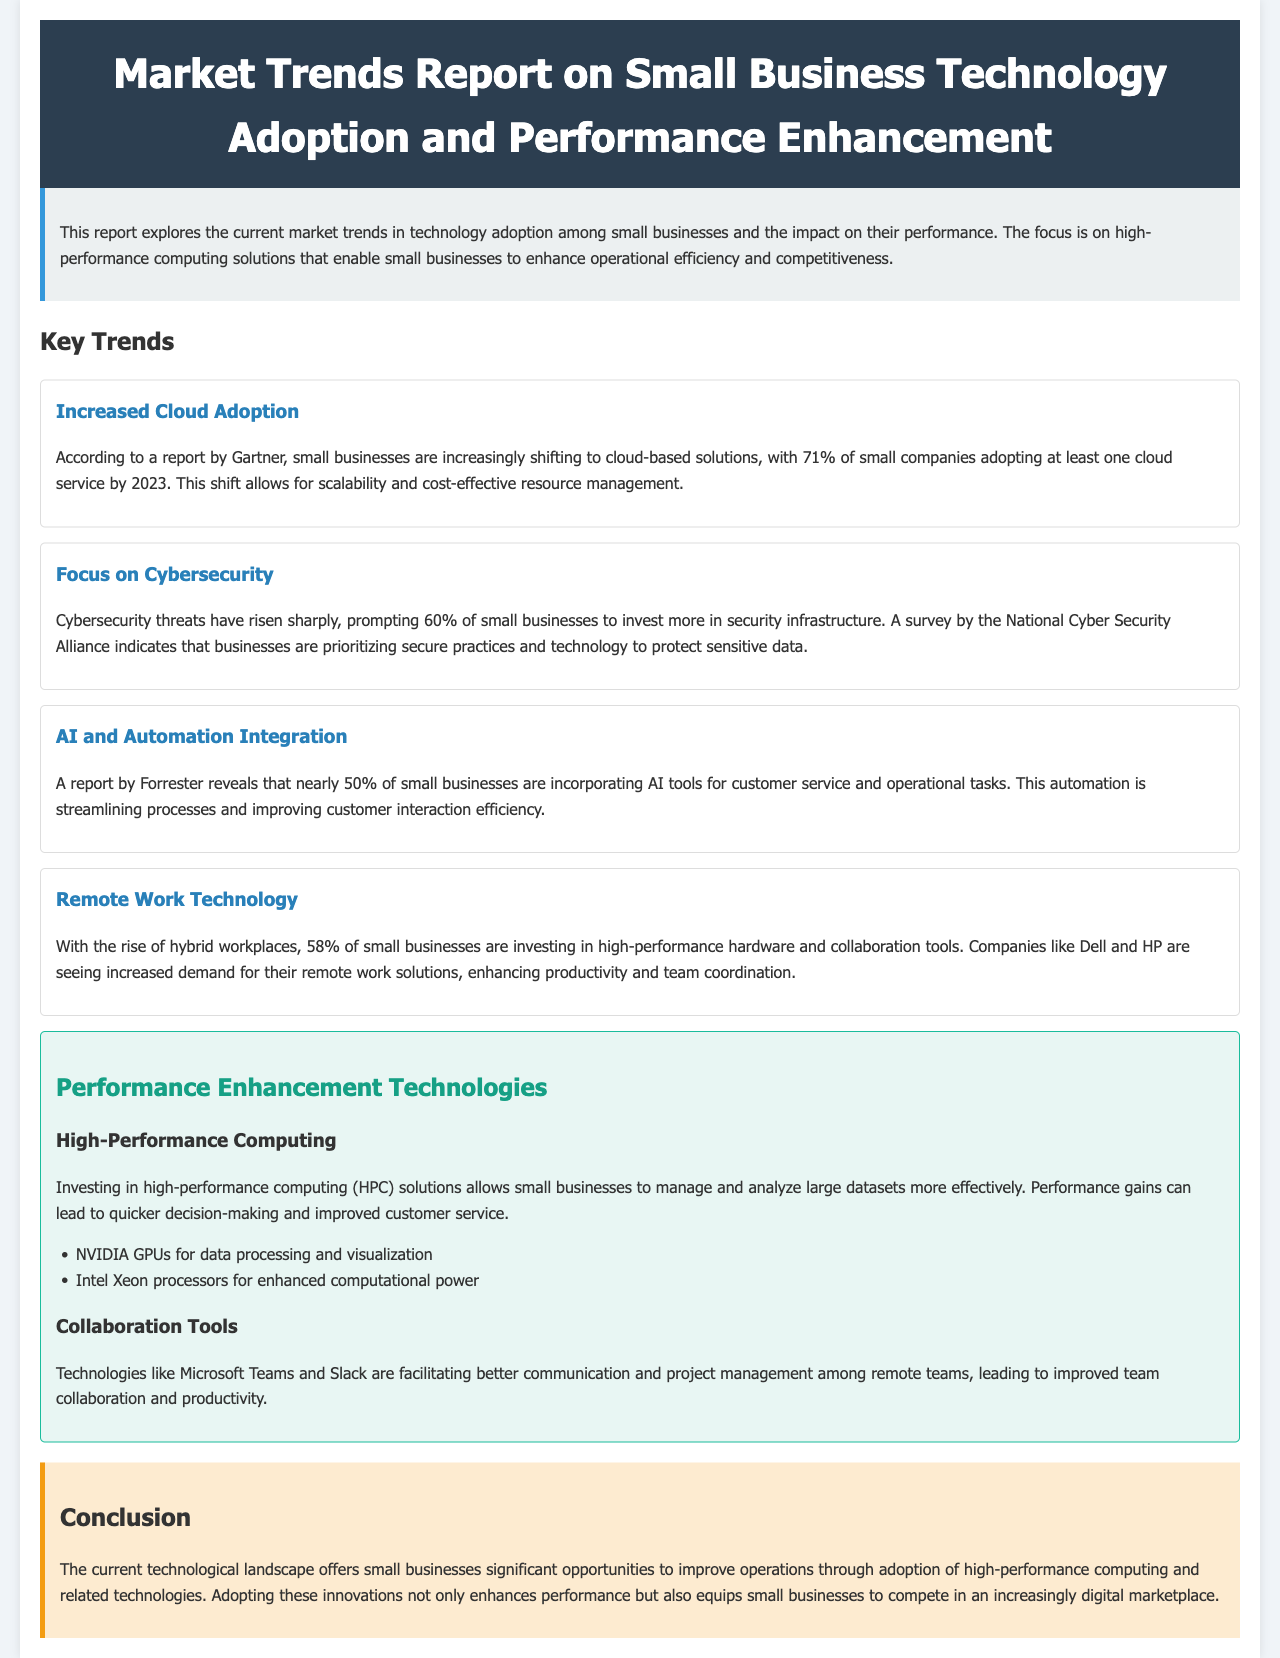What percentage of small businesses adopted at least one cloud service by 2023? According to the report, 71% of small companies adopted at least one cloud service by 2023.
Answer: 71% What is the focus of 60% of small businesses regarding technology investment? The report states that 60% of small businesses are investing more in security infrastructure due to rising cybersecurity threats.
Answer: Cybersecurity Which AI tool integration percentage is mentioned in the report? The report reveals that nearly 50% of small businesses are incorporating AI tools for customer service and operational tasks.
Answer: 50% What type of hardware are 58% of small businesses investing in? The document indicates that 58% of small businesses are investing in high-performance hardware and collaboration tools.
Answer: High-performance hardware What is one technology mentioned that facilitates better communication among remote teams? The report mentions technologies like Microsoft Teams and Slack as tools that facilitate better communication among remote teams.
Answer: Microsoft Teams How much does the document say high-performance computing solutions can improve decision-making? The document mentions that high-performance computing solutions allow for quicker decision-making.
Answer: Quicker What is the primary benefit of adopting high-performance computing, as detailed in the report? The report states that adopting high-performance computing enhances operational efficiency and competitiveness for small businesses.
Answer: Operational efficiency Which companies are noted for increased demand in remote work solutions? The document states that companies like Dell and HP are experiencing increased demand for their remote work solutions.
Answer: Dell and HP 